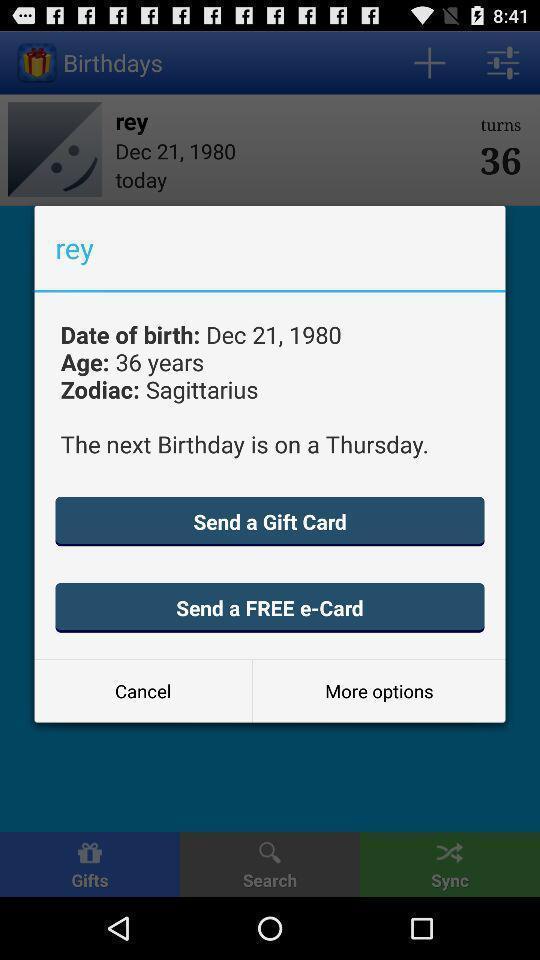Give me a narrative description of this picture. Pop-up shows birthday details. 